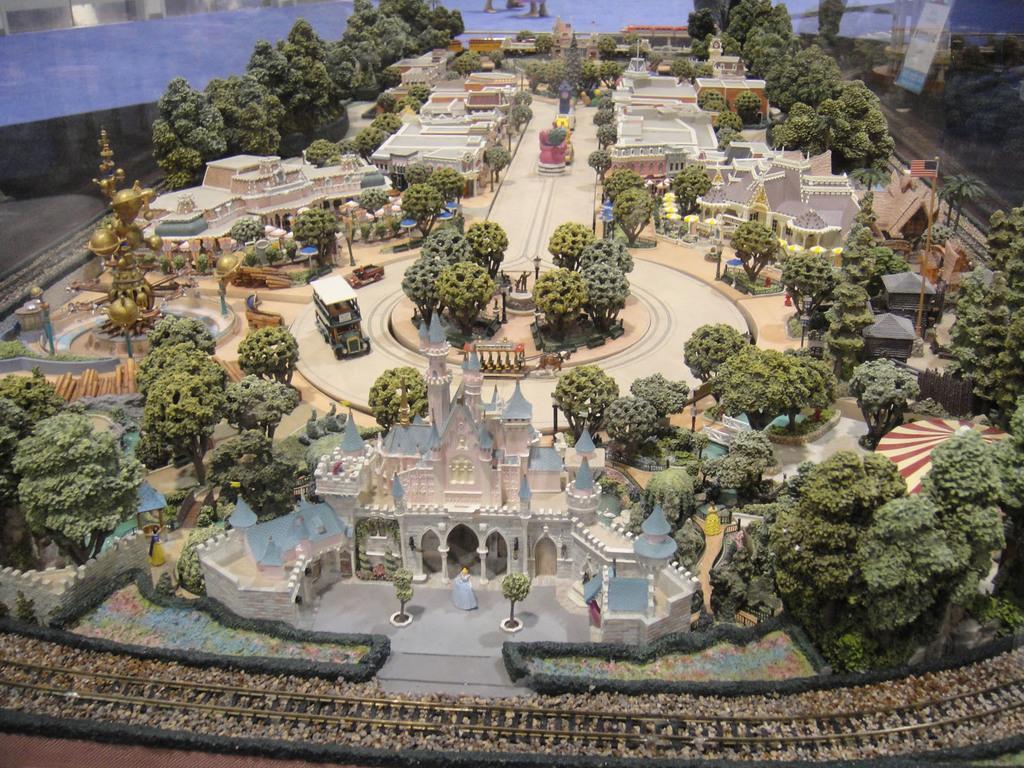Could you give a brief overview of what you see in this image? This is an imaginary construction of a kingdom with a palace and a king and queen with so many trees, buildings, a track and many other objects.  